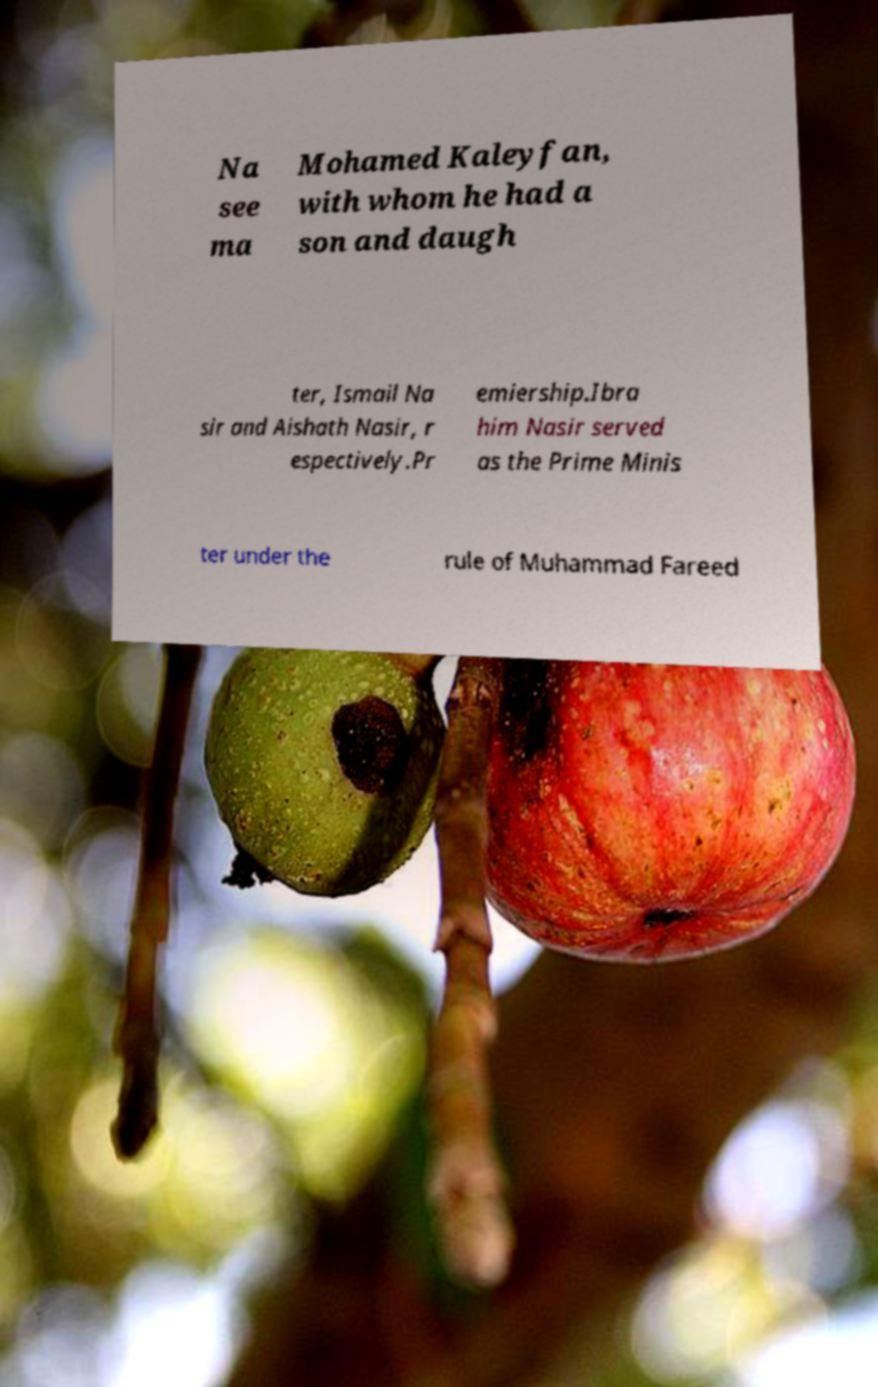There's text embedded in this image that I need extracted. Can you transcribe it verbatim? Na see ma Mohamed Kaleyfan, with whom he had a son and daugh ter, Ismail Na sir and Aishath Nasir, r espectively.Pr emiership.Ibra him Nasir served as the Prime Minis ter under the rule of Muhammad Fareed 